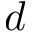Convert formula to latex. <formula><loc_0><loc_0><loc_500><loc_500>d</formula> 